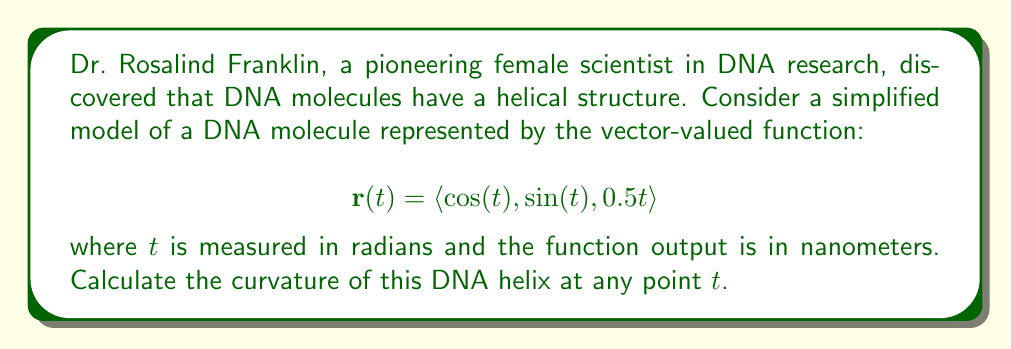Can you solve this math problem? To calculate the curvature of a vector-valued function, we use the formula:

$$\kappa = \frac{|\mathbf{r}'(t) \times \mathbf{r}''(t)|}{|\mathbf{r}'(t)|^3}$$

Let's follow these steps:

1) First, we need to find $\mathbf{r}'(t)$:
   $$\mathbf{r}'(t) = \langle -\sin(t), \cos(t), 0.5 \rangle$$

2) Next, we calculate $\mathbf{r}''(t)$:
   $$\mathbf{r}''(t) = \langle -\cos(t), -\sin(t), 0 \rangle$$

3) Now, we compute $\mathbf{r}'(t) \times \mathbf{r}''(t)$:
   $$\begin{align}
   \mathbf{r}'(t) \times \mathbf{r}''(t) &= \begin{vmatrix} 
   \mathbf{i} & \mathbf{j} & \mathbf{k} \\
   -\sin(t) & \cos(t) & 0.5 \\
   -\cos(t) & -\sin(t) & 0
   \end{vmatrix} \\
   &= \langle -0.5\sin(t), -0.5\cos(t), -\sin^2(t) - \cos^2(t) \rangle \\
   &= \langle -0.5\sin(t), -0.5\cos(t), -1 \rangle
   \end{align}$$

4) Calculate $|\mathbf{r}'(t) \times \mathbf{r}''(t)|$:
   $$|\mathbf{r}'(t) \times \mathbf{r}''(t)| = \sqrt{0.25\sin^2(t) + 0.25\cos^2(t) + 1} = \sqrt{1.25}$$

5) Calculate $|\mathbf{r}'(t)|$:
   $$|\mathbf{r}'(t)| = \sqrt{\sin^2(t) + \cos^2(t) + 0.25} = \sqrt{1.25}$$

6) Now we can substitute these values into the curvature formula:
   $$\kappa = \frac{|\mathbf{r}'(t) \times \mathbf{r}''(t)|}{|\mathbf{r}'(t)|^3} = \frac{\sqrt{1.25}}{(\sqrt{1.25})^3} = \frac{\sqrt{1.25}}{(1.25)^{3/2}}$$

7) Simplify:
   $$\kappa = \frac{1}{\sqrt{1.25}} = \frac{\sqrt{5}}{5}$$
Answer: The curvature of the DNA helix at any point $t$ is $\kappa = \frac{\sqrt{5}}{5} \approx 0.4472$ nm⁻¹. 